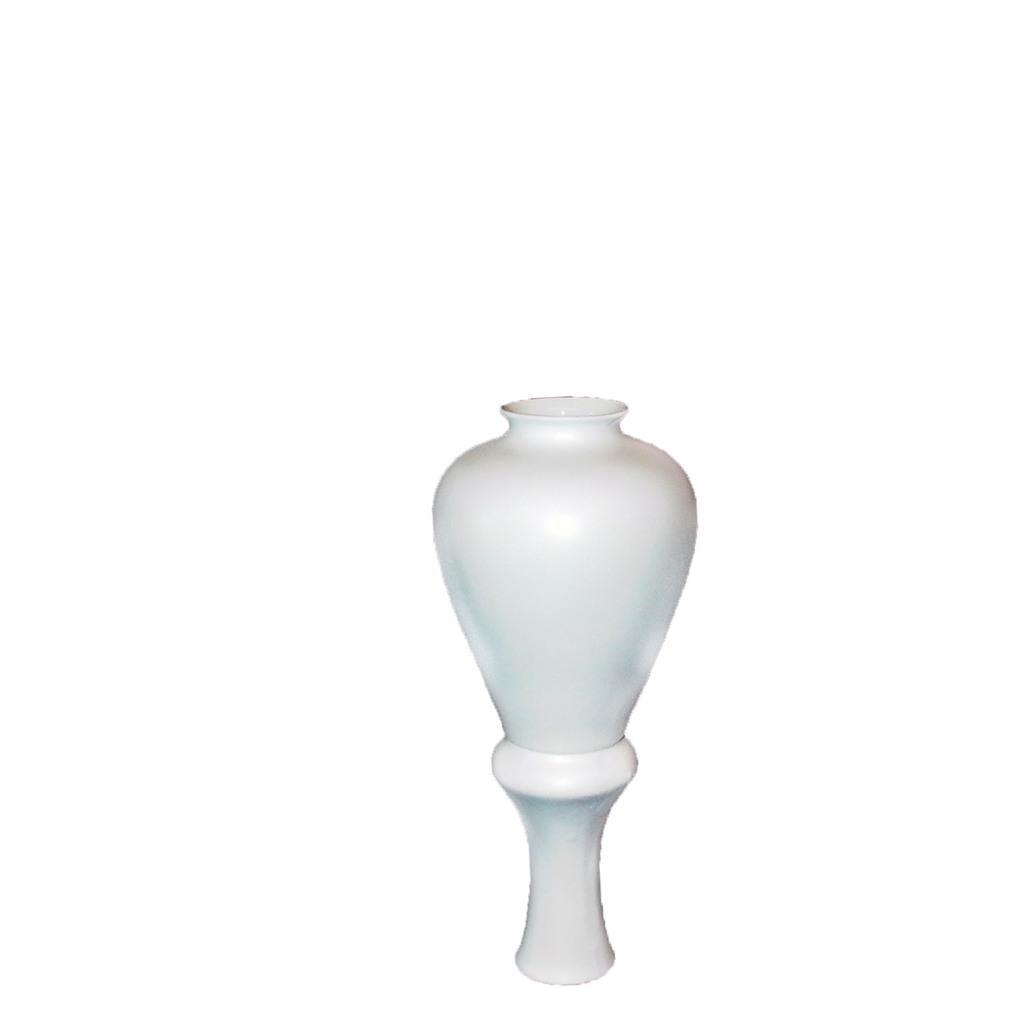Could you give a brief overview of what you see in this image? In this image we can see a white color object. 